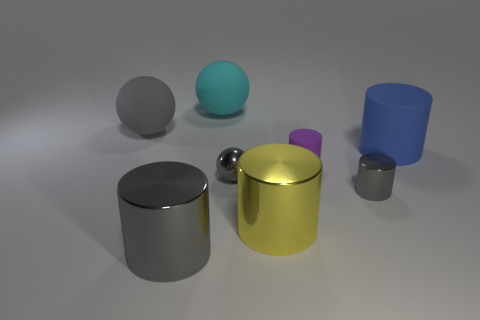What is the size of the other metallic cylinder that is the same color as the small shiny cylinder?
Your response must be concise. Large. What number of objects are either large cyan shiny cylinders or small gray metallic cylinders?
Offer a terse response. 1. There is a small gray metallic object on the left side of the gray cylinder that is behind the big yellow shiny object; what is its shape?
Offer a terse response. Sphere. Do the gray metal thing that is to the right of the purple rubber cylinder and the large gray metal object have the same shape?
Ensure brevity in your answer.  Yes. There is a cyan sphere that is the same material as the tiny purple thing; what size is it?
Offer a very short reply. Large. How many things are gray matte objects left of the large yellow shiny cylinder or big things that are behind the small purple matte object?
Give a very brief answer. 3. Are there an equal number of gray metal spheres right of the tiny matte cylinder and big cyan things that are right of the blue rubber object?
Provide a short and direct response. Yes. There is a matte object in front of the blue cylinder; what color is it?
Ensure brevity in your answer.  Purple. Is the color of the small sphere the same as the small metallic thing on the right side of the tiny rubber object?
Your answer should be very brief. Yes. Is the number of small yellow cylinders less than the number of big yellow metal objects?
Offer a terse response. Yes. 